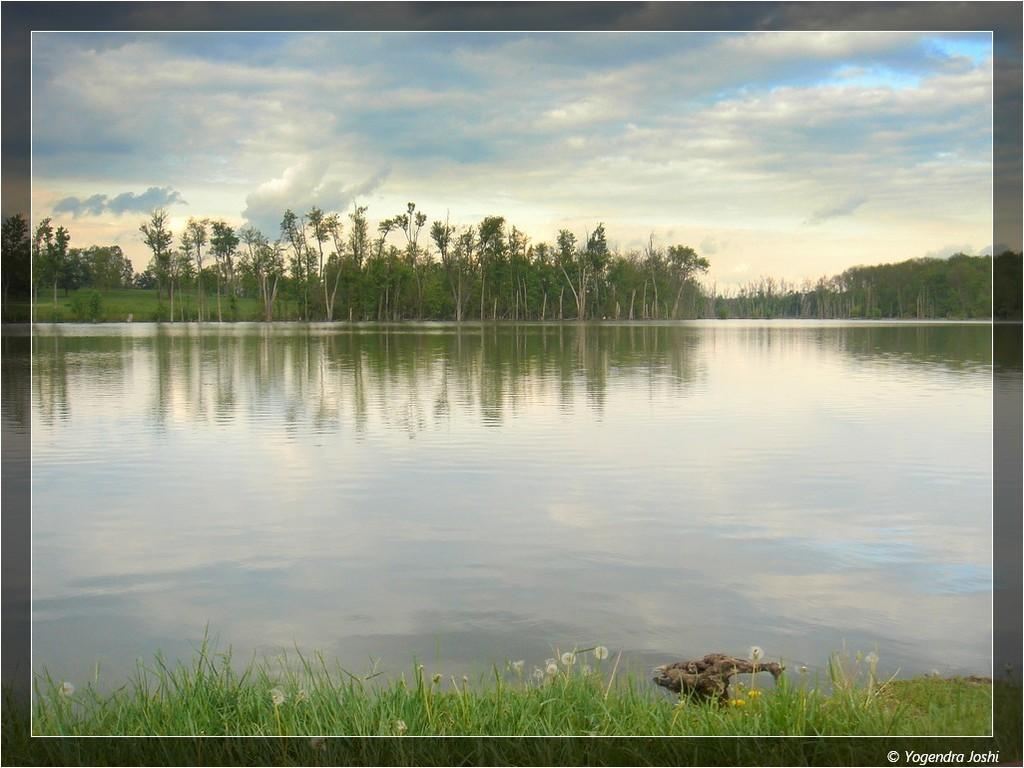What type of vegetation can be seen in the image? There is grass in the image. What else can be seen in the image besides grass? There is water and trees in the image. What is visible in the background of the image? The sky is visible in the background of the image. What can be seen in the sky? Clouds are present in the sky. What type of wealth is displayed in the image? There is no reference to wealth in the image; it features natural elements such as grass, water, trees, sky, and clouds. 